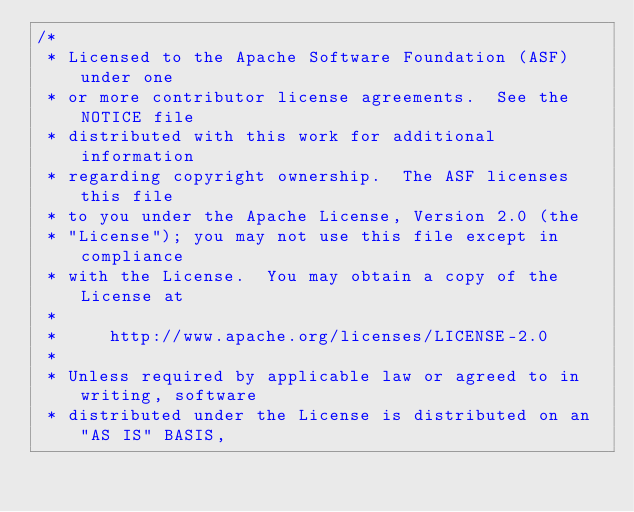Convert code to text. <code><loc_0><loc_0><loc_500><loc_500><_Java_>/*
 * Licensed to the Apache Software Foundation (ASF) under one
 * or more contributor license agreements.  See the NOTICE file
 * distributed with this work for additional information
 * regarding copyright ownership.  The ASF licenses this file
 * to you under the Apache License, Version 2.0 (the
 * "License"); you may not use this file except in compliance
 * with the License.  You may obtain a copy of the License at
 *
 *     http://www.apache.org/licenses/LICENSE-2.0
 *
 * Unless required by applicable law or agreed to in writing, software
 * distributed under the License is distributed on an "AS IS" BASIS,</code> 